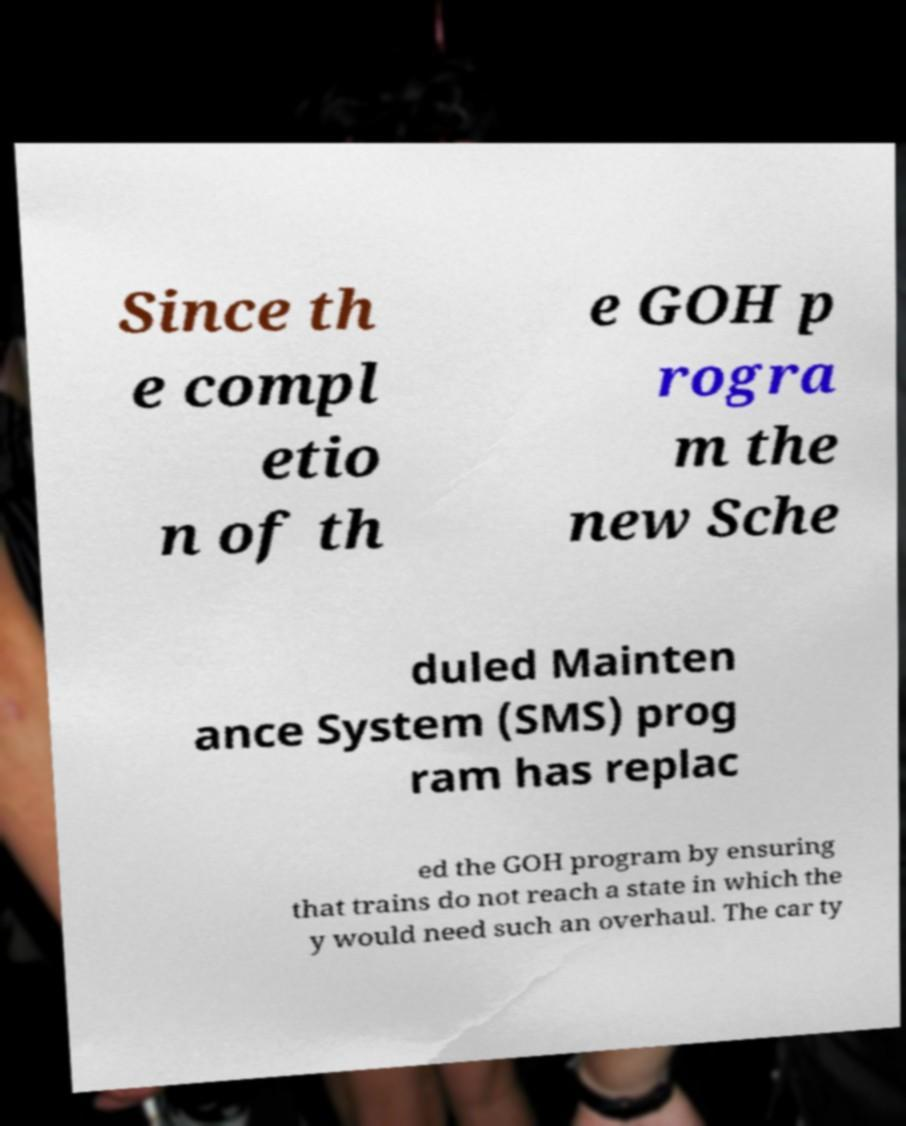I need the written content from this picture converted into text. Can you do that? Since th e compl etio n of th e GOH p rogra m the new Sche duled Mainten ance System (SMS) prog ram has replac ed the GOH program by ensuring that trains do not reach a state in which the y would need such an overhaul. The car ty 